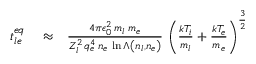<formula> <loc_0><loc_0><loc_500><loc_500>\begin{array} { r l r } { t _ { l e } ^ { e q } } & \approx } & { \frac { 4 \pi \epsilon _ { 0 } ^ { 2 } \, m _ { l } \, m _ { e } } { Z _ { l } ^ { 2 } \, q _ { e } ^ { 4 } \, n _ { e } \, \ln \Lambda \left ( n _ { l } , n _ { e } \right ) } \, \left ( \frac { k T _ { i } } { m _ { l } } + \frac { k T _ { e } } { m _ { e } } \right ) ^ { \frac { 3 } { 2 } } } \end{array}</formula> 